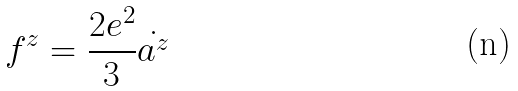Convert formula to latex. <formula><loc_0><loc_0><loc_500><loc_500>f ^ { z } = \frac { 2 e ^ { 2 } } { 3 } \dot { a ^ { z } }</formula> 